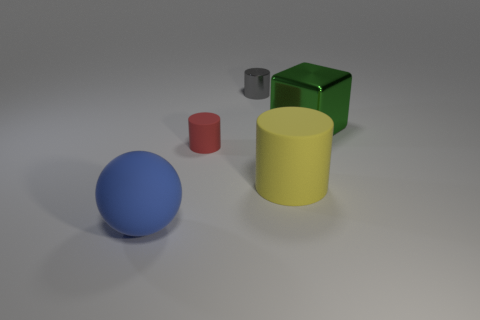Do the small gray thing and the ball have the same material?
Provide a short and direct response. No. How big is the matte object that is left of the matte cylinder that is on the left side of the rubber object that is on the right side of the small gray metal object?
Provide a succinct answer. Large. What number of other things are the same color as the sphere?
Offer a terse response. 0. What is the shape of the green object that is the same size as the blue matte ball?
Provide a short and direct response. Cube. What number of big things are either gray metallic cylinders or gray rubber cylinders?
Provide a succinct answer. 0. Are there any rubber objects that are in front of the tiny cylinder on the left side of the cylinder behind the tiny red object?
Your answer should be compact. Yes. Are there any yellow matte things of the same size as the rubber sphere?
Your answer should be compact. Yes. There is a yellow cylinder that is the same size as the cube; what is it made of?
Offer a terse response. Rubber. Do the ball and the cylinder that is behind the large green metal cube have the same size?
Provide a short and direct response. No. How many metallic objects are tiny gray objects or small brown blocks?
Make the answer very short. 1. 